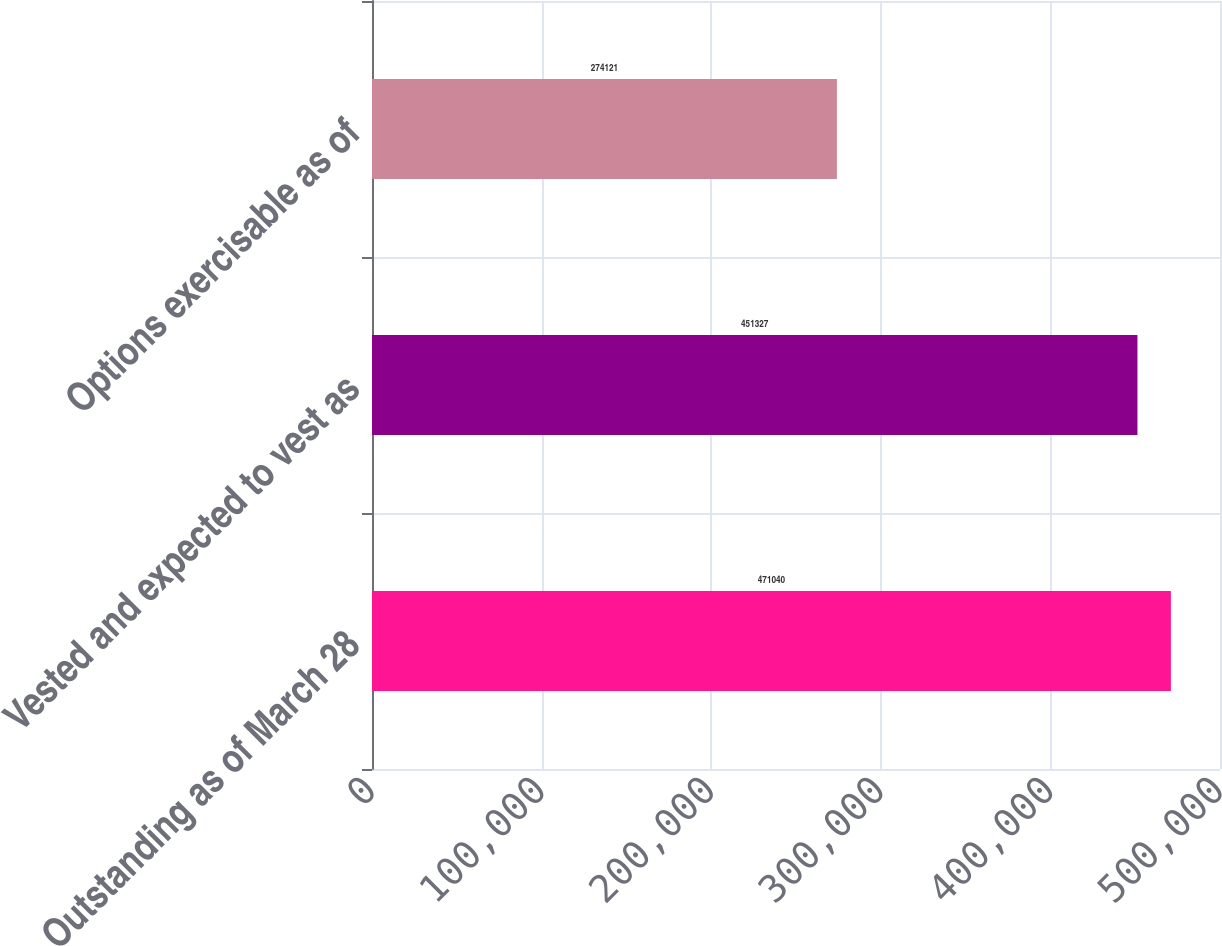Convert chart to OTSL. <chart><loc_0><loc_0><loc_500><loc_500><bar_chart><fcel>Outstanding as of March 28<fcel>Vested and expected to vest as<fcel>Options exercisable as of<nl><fcel>471040<fcel>451327<fcel>274121<nl></chart> 